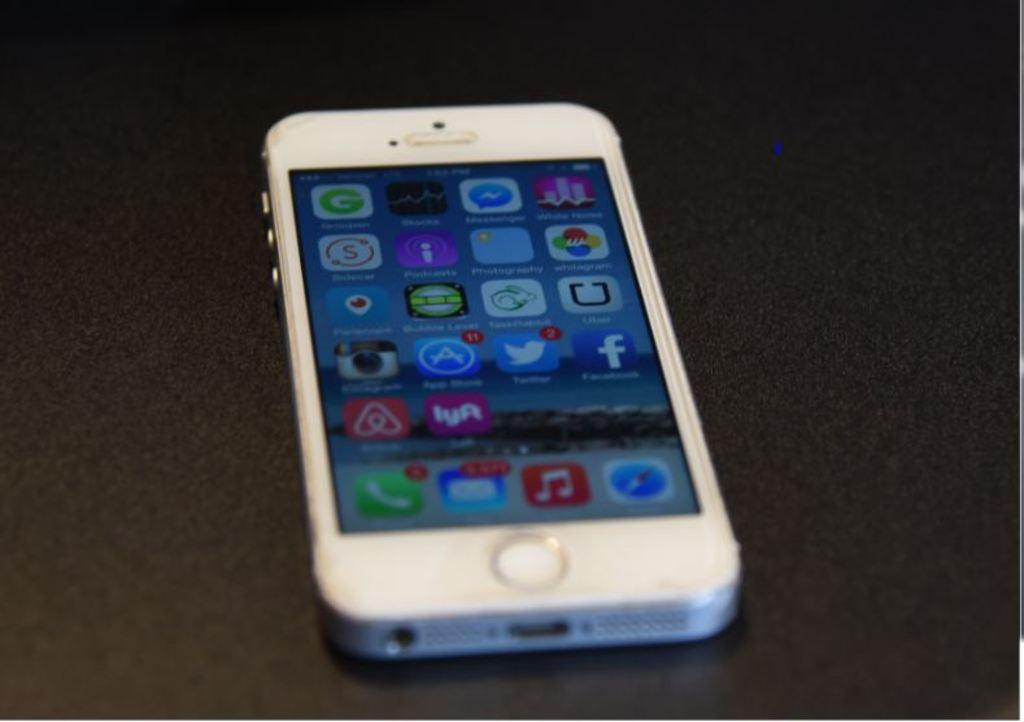What is the name of the app with the giant f on its icon?
Give a very brief answer. Facebook. 